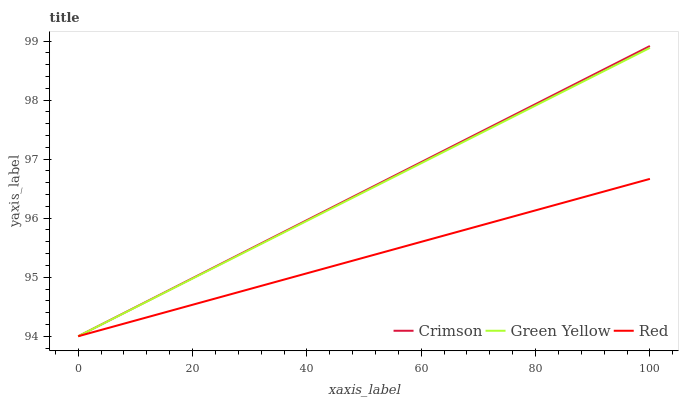Does Red have the minimum area under the curve?
Answer yes or no. Yes. Does Crimson have the maximum area under the curve?
Answer yes or no. Yes. Does Green Yellow have the minimum area under the curve?
Answer yes or no. No. Does Green Yellow have the maximum area under the curve?
Answer yes or no. No. Is Crimson the smoothest?
Answer yes or no. Yes. Is Green Yellow the roughest?
Answer yes or no. Yes. Is Red the smoothest?
Answer yes or no. No. Is Red the roughest?
Answer yes or no. No. Does Crimson have the lowest value?
Answer yes or no. Yes. Does Crimson have the highest value?
Answer yes or no. Yes. Does Green Yellow have the highest value?
Answer yes or no. No. Does Red intersect Green Yellow?
Answer yes or no. Yes. Is Red less than Green Yellow?
Answer yes or no. No. Is Red greater than Green Yellow?
Answer yes or no. No. 